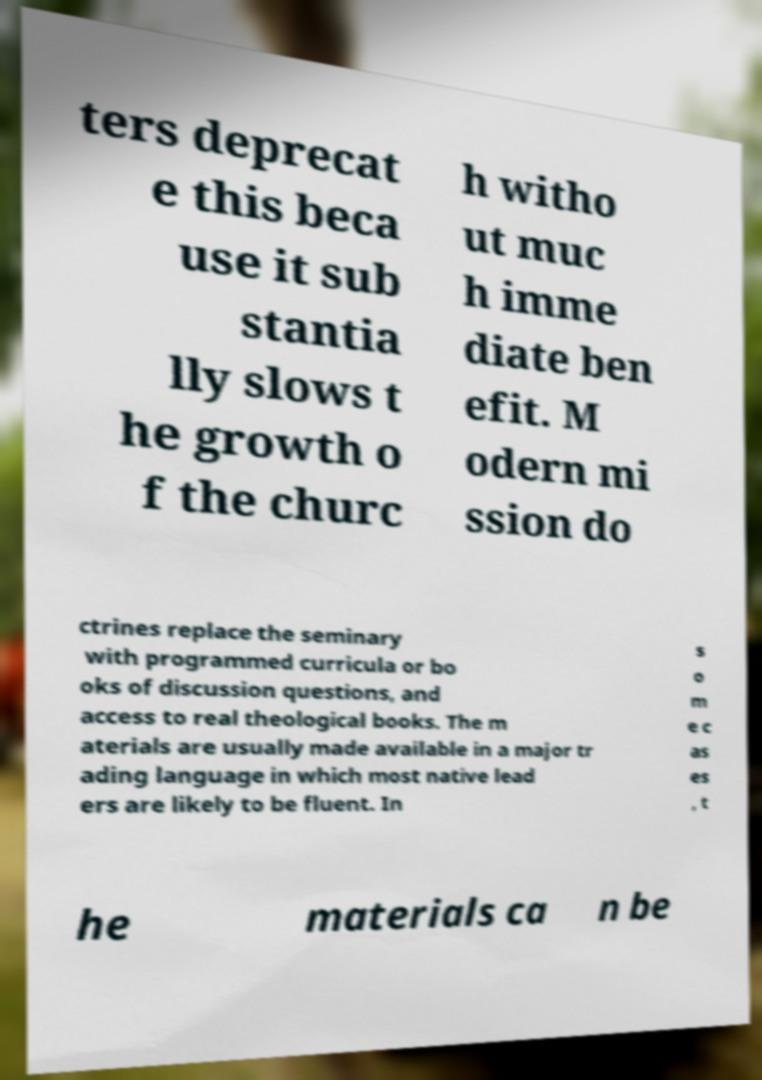Can you accurately transcribe the text from the provided image for me? ters deprecat e this beca use it sub stantia lly slows t he growth o f the churc h witho ut muc h imme diate ben efit. M odern mi ssion do ctrines replace the seminary with programmed curricula or bo oks of discussion questions, and access to real theological books. The m aterials are usually made available in a major tr ading language in which most native lead ers are likely to be fluent. In s o m e c as es , t he materials ca n be 